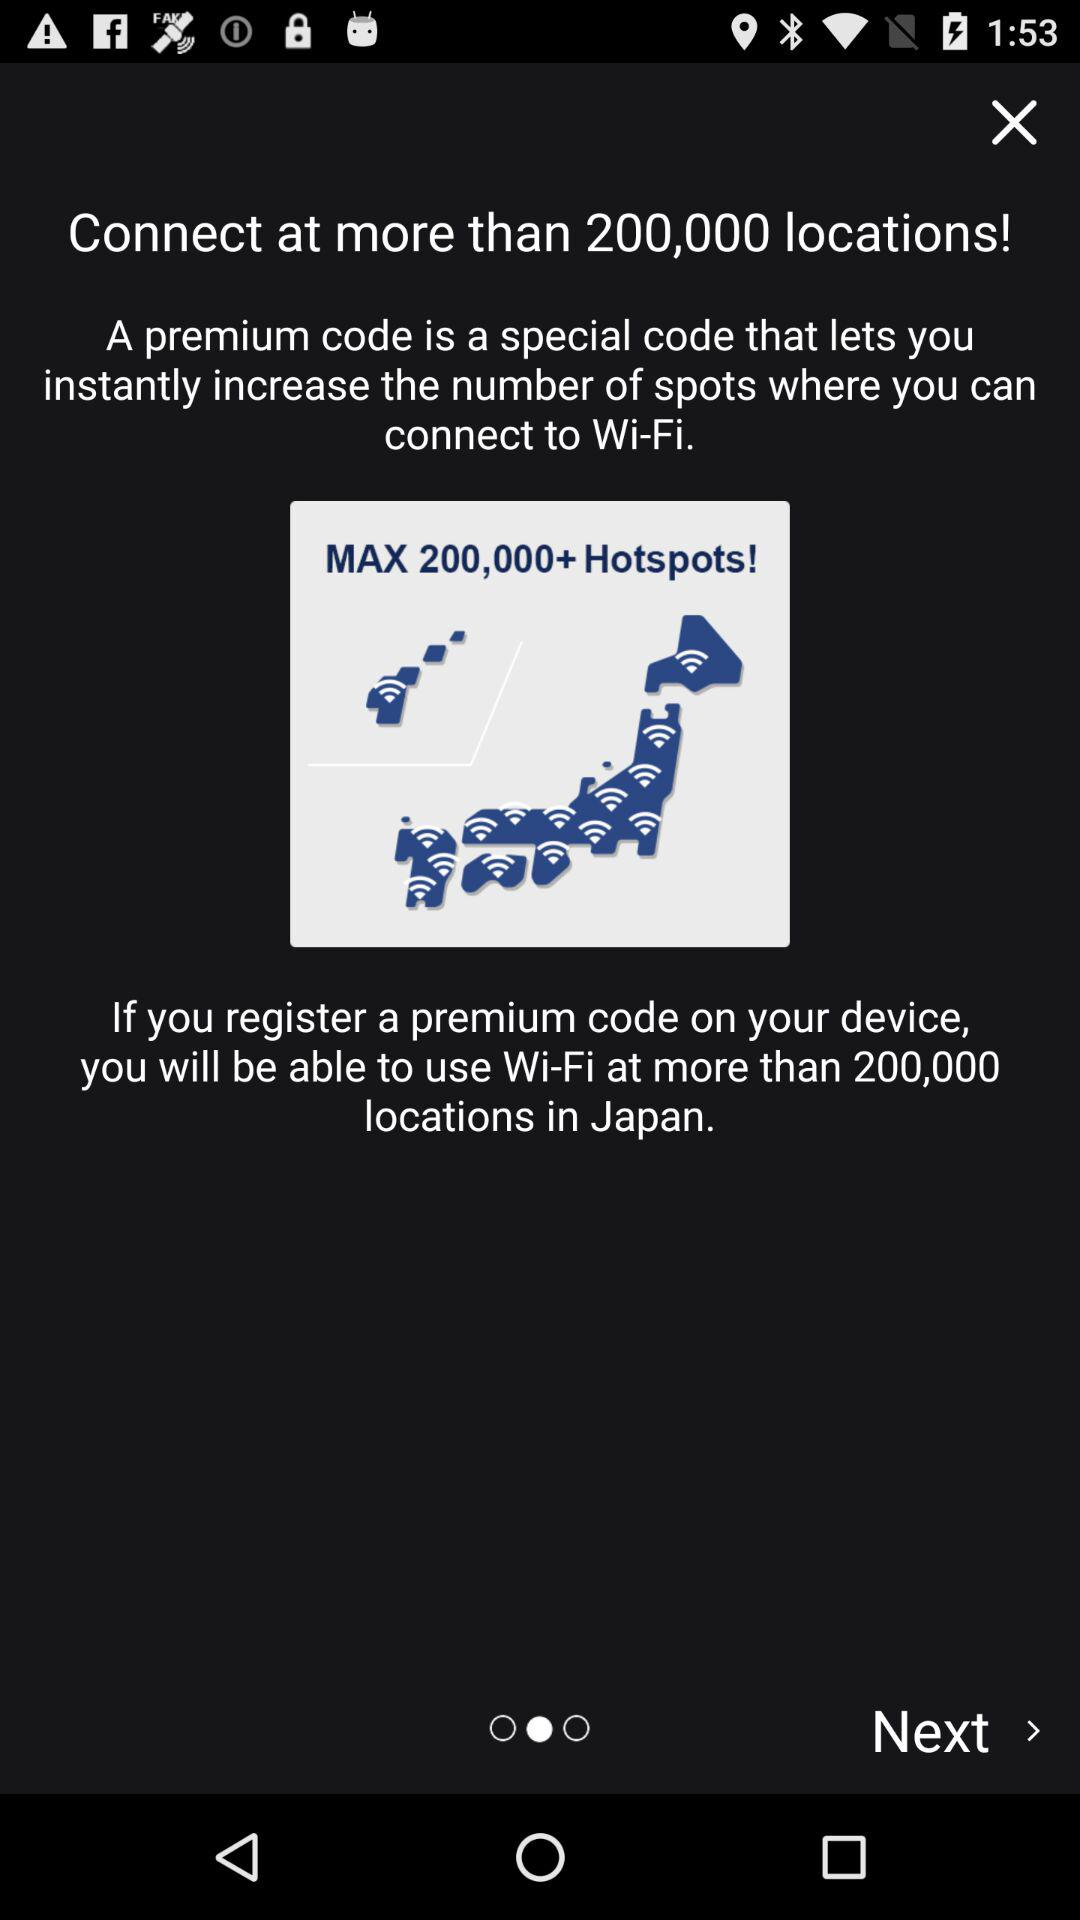How many locations are there to which we can connect? There are 200,000 locations to which we can connect. 